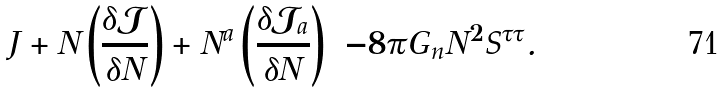<formula> <loc_0><loc_0><loc_500><loc_500>J + N \left ( \frac { \delta \mathcal { J } } { \delta N } \right ) + N ^ { a } \left ( \frac { \delta \mathcal { J } _ { a } } { \delta N } \right ) = - 8 \pi G _ { n } N ^ { 2 } S ^ { \tau \tau } .</formula> 